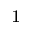Convert formula to latex. <formula><loc_0><loc_0><loc_500><loc_500>^ { 1 }</formula> 